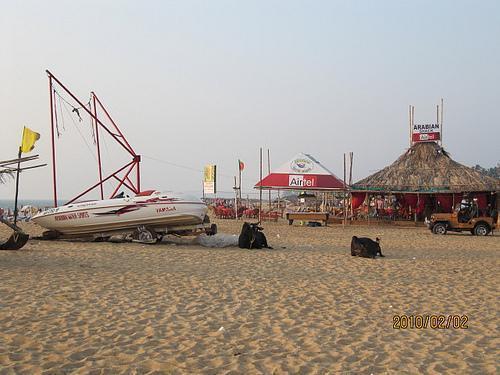What type of geographical feature is located near this area?
Indicate the correct choice and explain in the format: 'Answer: answer
Rationale: rationale.'
Options: Desert, ocean, mountain, mesa. Answer: ocean.
Rationale: The type is the ocean. 